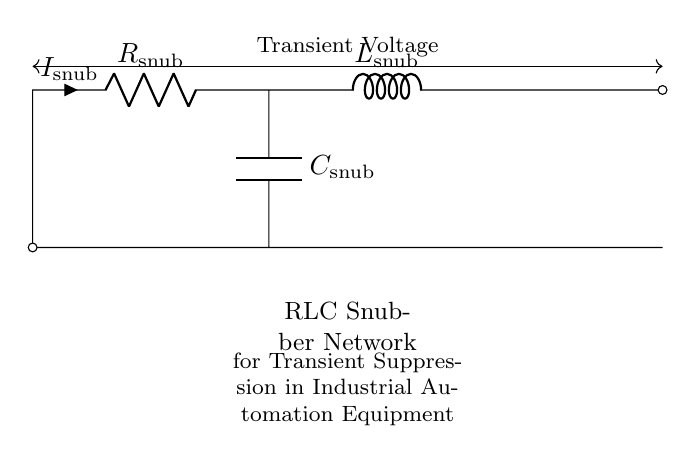What are the components of the RLC snubber network? The components are a resistor, an inductor, and a capacitor that are used together in the circuit as indicated by their labels.
Answer: resistor, inductor, capacitor What is the purpose of the RLC snubber network? The purpose of the RLC snubber network is to suppress transient voltages across industrial automation equipment, protecting against voltage spikes.
Answer: transient suppression What is labeled as the capacitor in the circuit? The component labeled with the symbol for capacitance in the circuit is indicated as C_snub, which is the capacitor.
Answer: C_snub How many components are in the RLC snubber network? There are three main components in this RLC snubber network: a resistor, an inductor, and a capacitor.
Answer: three What is the current flowing through the RLC snubber network labeled as? The current flowing through the resistor in the circuit is labeled as I_snub, indicating the current in the circuit.
Answer: I_snub In what arrangement are the components connected in the circuit? The resistor is in series with the inductor and the capacitor is parallel to the resistor, forming a series-parallel configuration typical of RLC circuits.
Answer: series-parallel What voltage is the snubber network designed to handle? The snubber is designed to handle transient voltages, which are indicated above the circuit in the diagram.
Answer: transient voltage 